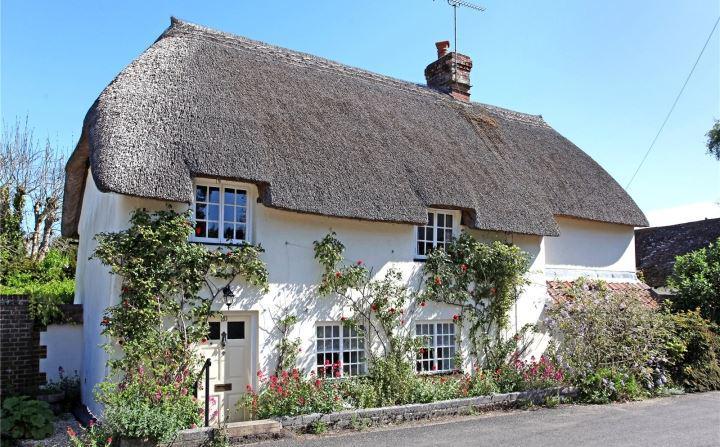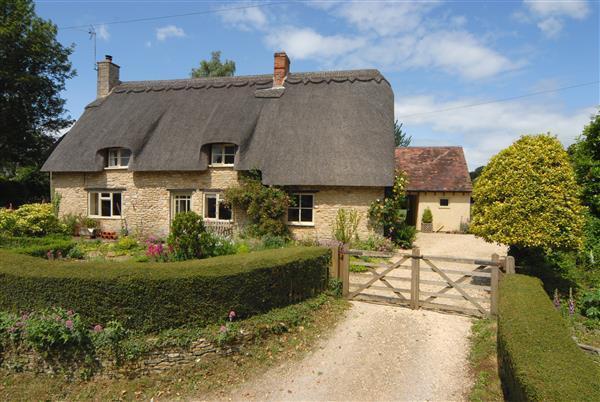The first image is the image on the left, the second image is the image on the right. Examine the images to the left and right. Is the description "In at least one image there are a total of five window on the main house at atleast one chimney ." accurate? Answer yes or no. Yes. 